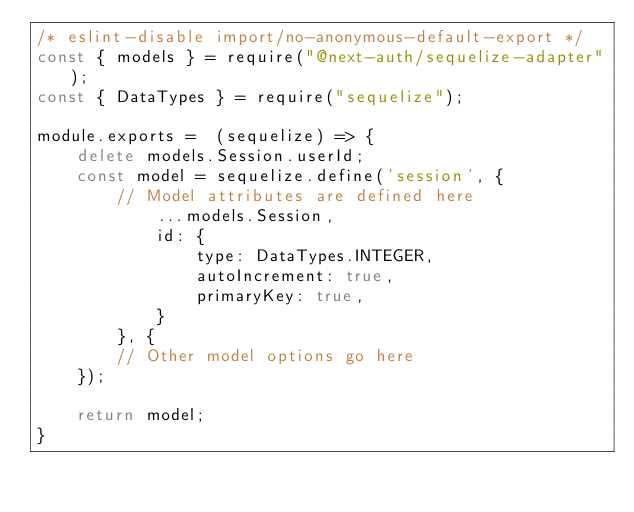<code> <loc_0><loc_0><loc_500><loc_500><_JavaScript_>/* eslint-disable import/no-anonymous-default-export */
const { models } = require("@next-auth/sequelize-adapter");
const { DataTypes } = require("sequelize");

module.exports =  (sequelize) => {
    delete models.Session.userId;
    const model = sequelize.define('session', {
        // Model attributes are defined here
            ...models.Session,
            id: {
                type: DataTypes.INTEGER,
                autoIncrement: true,
                primaryKey: true,
            }
        }, {
        // Other model options go here
    });
    
    return model;
}
</code> 